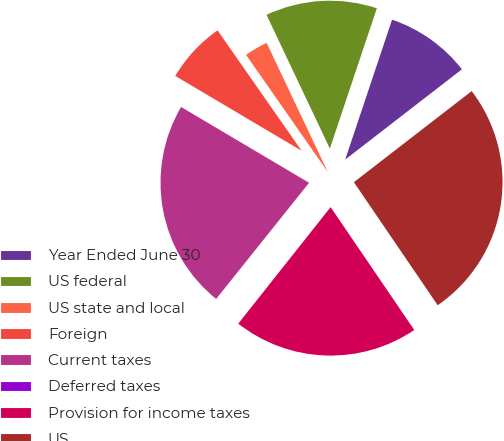Convert chart to OTSL. <chart><loc_0><loc_0><loc_500><loc_500><pie_chart><fcel>Year Ended June 30<fcel>US federal<fcel>US state and local<fcel>Foreign<fcel>Current taxes<fcel>Deferred taxes<fcel>Provision for income taxes<fcel>US<nl><fcel>9.38%<fcel>12.18%<fcel>2.66%<fcel>6.79%<fcel>22.77%<fcel>0.07%<fcel>20.18%<fcel>25.96%<nl></chart> 